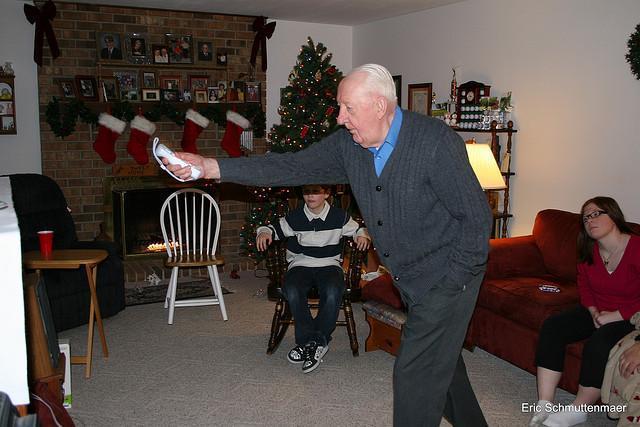How many stockings are on the fireplace?
Give a very brief answer. 4. How many people are standing?
Give a very brief answer. 1. How many couches are in the photo?
Give a very brief answer. 2. How many chairs can you see?
Give a very brief answer. 2. How many people can you see?
Give a very brief answer. 4. 